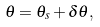<formula> <loc_0><loc_0><loc_500><loc_500>\theta = \theta _ { s } + \delta \theta ,</formula> 